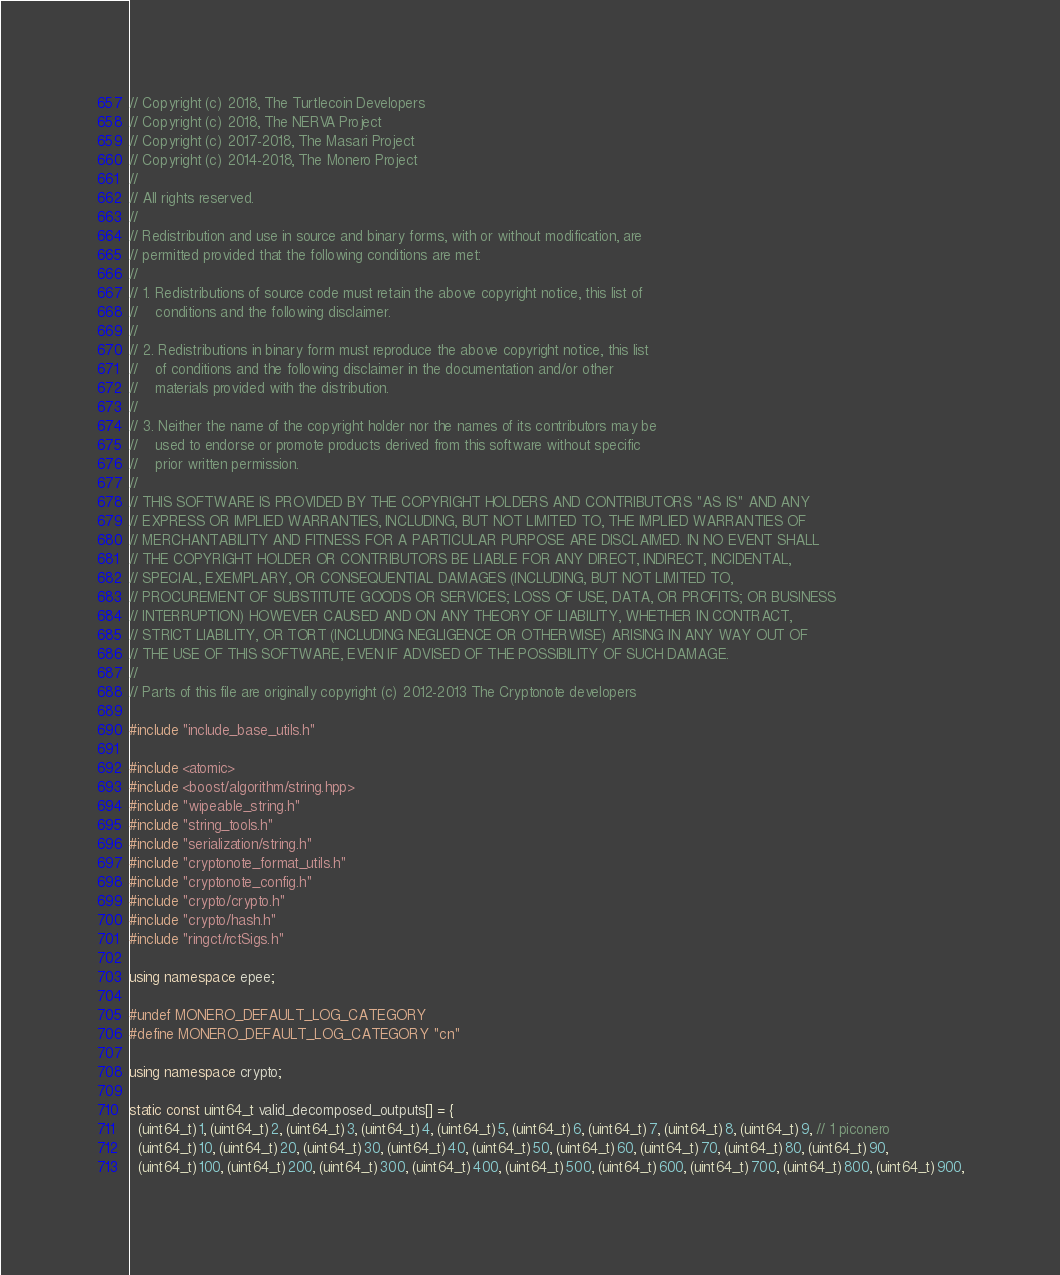Convert code to text. <code><loc_0><loc_0><loc_500><loc_500><_C++_>// Copyright (c) 2018, The Turtlecoin Developers
// Copyright (c) 2018, The NERVA Project
// Copyright (c) 2017-2018, The Masari Project
// Copyright (c) 2014-2018, The Monero Project
// 
// All rights reserved.
// 
// Redistribution and use in source and binary forms, with or without modification, are
// permitted provided that the following conditions are met:
// 
// 1. Redistributions of source code must retain the above copyright notice, this list of
//    conditions and the following disclaimer.
// 
// 2. Redistributions in binary form must reproduce the above copyright notice, this list
//    of conditions and the following disclaimer in the documentation and/or other
//    materials provided with the distribution.
// 
// 3. Neither the name of the copyright holder nor the names of its contributors may be
//    used to endorse or promote products derived from this software without specific
//    prior written permission.
// 
// THIS SOFTWARE IS PROVIDED BY THE COPYRIGHT HOLDERS AND CONTRIBUTORS "AS IS" AND ANY
// EXPRESS OR IMPLIED WARRANTIES, INCLUDING, BUT NOT LIMITED TO, THE IMPLIED WARRANTIES OF
// MERCHANTABILITY AND FITNESS FOR A PARTICULAR PURPOSE ARE DISCLAIMED. IN NO EVENT SHALL
// THE COPYRIGHT HOLDER OR CONTRIBUTORS BE LIABLE FOR ANY DIRECT, INDIRECT, INCIDENTAL,
// SPECIAL, EXEMPLARY, OR CONSEQUENTIAL DAMAGES (INCLUDING, BUT NOT LIMITED TO,
// PROCUREMENT OF SUBSTITUTE GOODS OR SERVICES; LOSS OF USE, DATA, OR PROFITS; OR BUSINESS
// INTERRUPTION) HOWEVER CAUSED AND ON ANY THEORY OF LIABILITY, WHETHER IN CONTRACT,
// STRICT LIABILITY, OR TORT (INCLUDING NEGLIGENCE OR OTHERWISE) ARISING IN ANY WAY OUT OF
// THE USE OF THIS SOFTWARE, EVEN IF ADVISED OF THE POSSIBILITY OF SUCH DAMAGE.
// 
// Parts of this file are originally copyright (c) 2012-2013 The Cryptonote developers

#include "include_base_utils.h"

#include <atomic>
#include <boost/algorithm/string.hpp>
#include "wipeable_string.h"
#include "string_tools.h"
#include "serialization/string.h"
#include "cryptonote_format_utils.h"
#include "cryptonote_config.h"
#include "crypto/crypto.h"
#include "crypto/hash.h"
#include "ringct/rctSigs.h"

using namespace epee;

#undef MONERO_DEFAULT_LOG_CATEGORY
#define MONERO_DEFAULT_LOG_CATEGORY "cn"

using namespace crypto;

static const uint64_t valid_decomposed_outputs[] = {
  (uint64_t)1, (uint64_t)2, (uint64_t)3, (uint64_t)4, (uint64_t)5, (uint64_t)6, (uint64_t)7, (uint64_t)8, (uint64_t)9, // 1 piconero
  (uint64_t)10, (uint64_t)20, (uint64_t)30, (uint64_t)40, (uint64_t)50, (uint64_t)60, (uint64_t)70, (uint64_t)80, (uint64_t)90,
  (uint64_t)100, (uint64_t)200, (uint64_t)300, (uint64_t)400, (uint64_t)500, (uint64_t)600, (uint64_t)700, (uint64_t)800, (uint64_t)900,</code> 